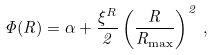Convert formula to latex. <formula><loc_0><loc_0><loc_500><loc_500>\Phi ( R ) = \alpha + \frac { \xi ^ { R } } { 2 } \left ( \frac { R } { R _ { \max } } \right ) ^ { 2 } \, ,</formula> 